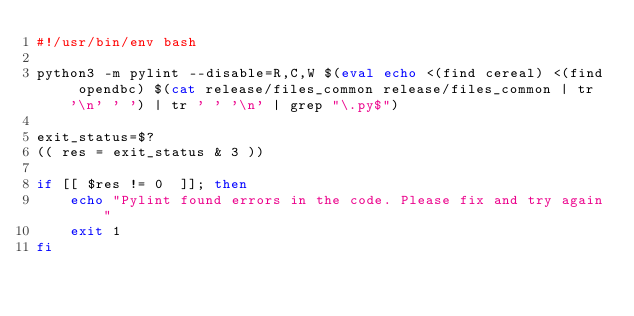<code> <loc_0><loc_0><loc_500><loc_500><_Bash_>#!/usr/bin/env bash

python3 -m pylint --disable=R,C,W $(eval echo <(find cereal) <(find opendbc) $(cat release/files_common release/files_common | tr '\n' ' ') | tr ' ' '\n' | grep "\.py$")

exit_status=$?
(( res = exit_status & 3 ))

if [[ $res != 0  ]]; then
	echo "Pylint found errors in the code. Please fix and try again"
	exit 1
fi
</code> 